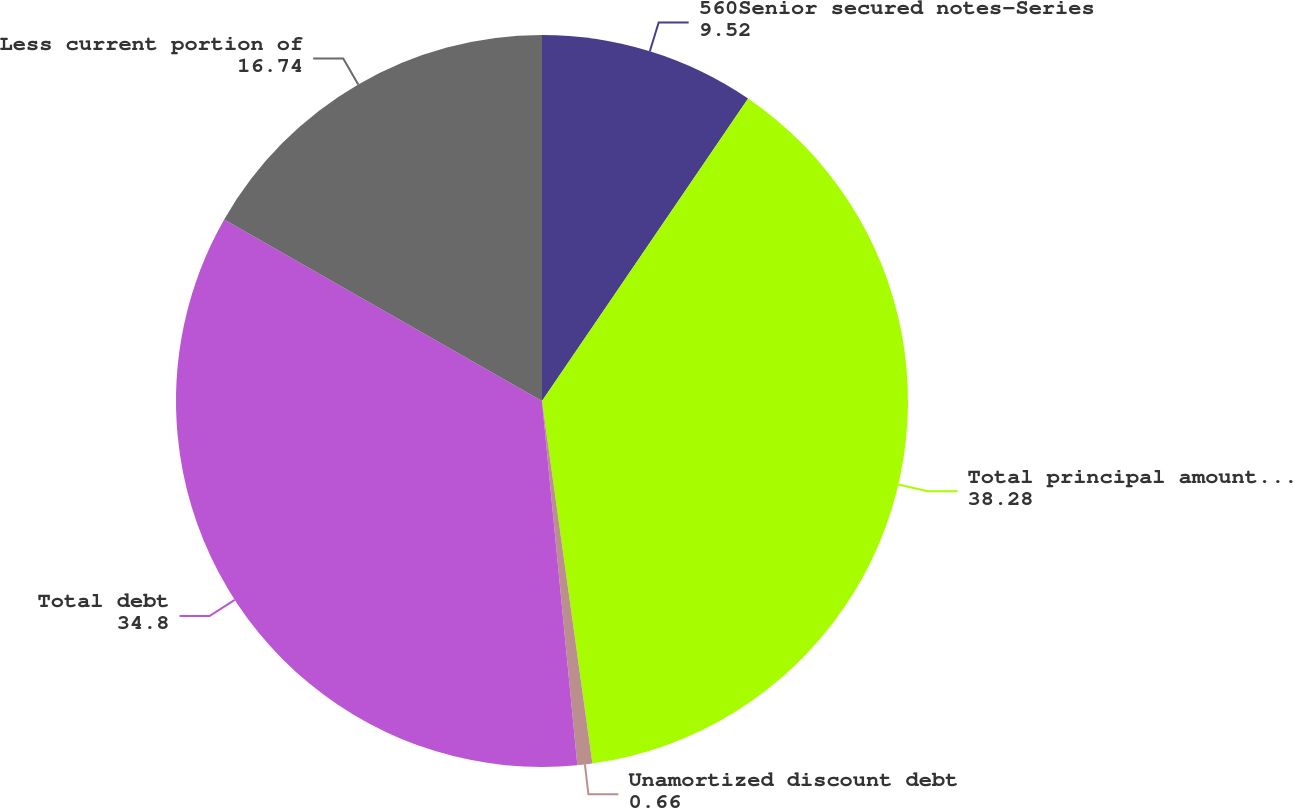<chart> <loc_0><loc_0><loc_500><loc_500><pie_chart><fcel>560Senior secured notes-Series<fcel>Total principal amount of debt<fcel>Unamortized discount debt<fcel>Total debt<fcel>Less current portion of<nl><fcel>9.52%<fcel>38.28%<fcel>0.66%<fcel>34.8%<fcel>16.74%<nl></chart> 